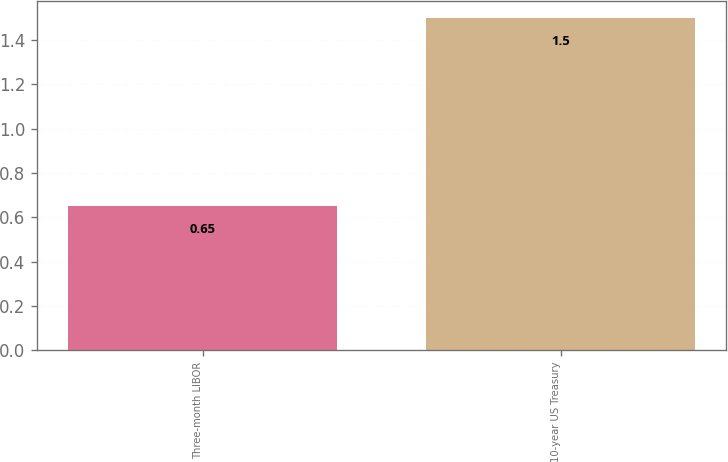<chart> <loc_0><loc_0><loc_500><loc_500><bar_chart><fcel>Three-month LIBOR<fcel>10-year US Treasury<nl><fcel>0.65<fcel>1.5<nl></chart> 